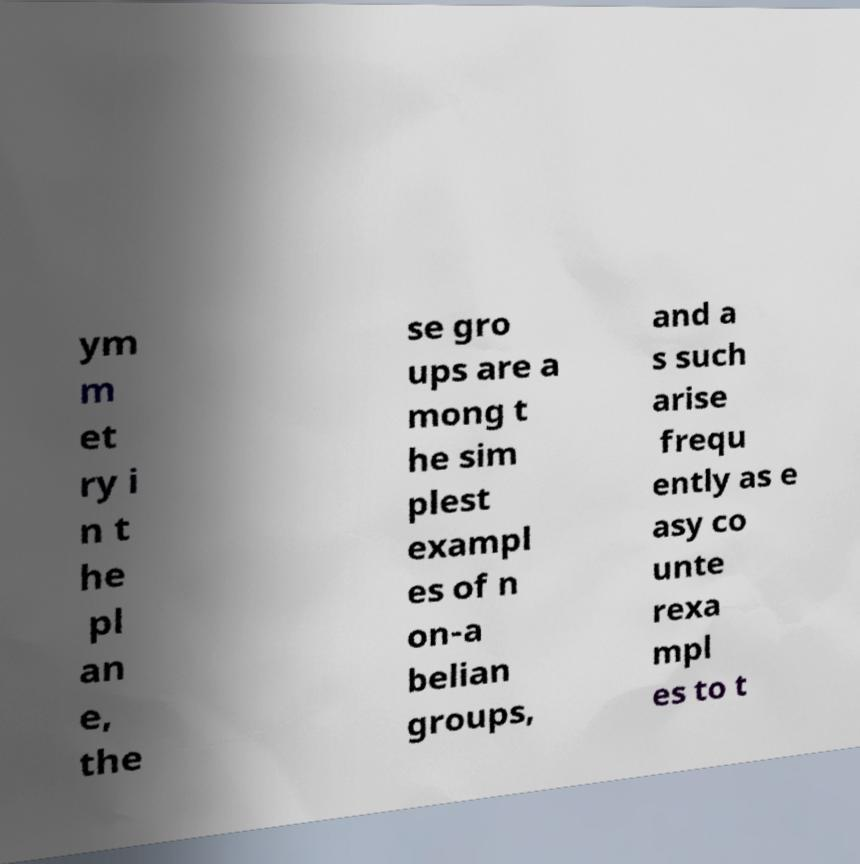Can you read and provide the text displayed in the image?This photo seems to have some interesting text. Can you extract and type it out for me? ym m et ry i n t he pl an e, the se gro ups are a mong t he sim plest exampl es of n on-a belian groups, and a s such arise frequ ently as e asy co unte rexa mpl es to t 